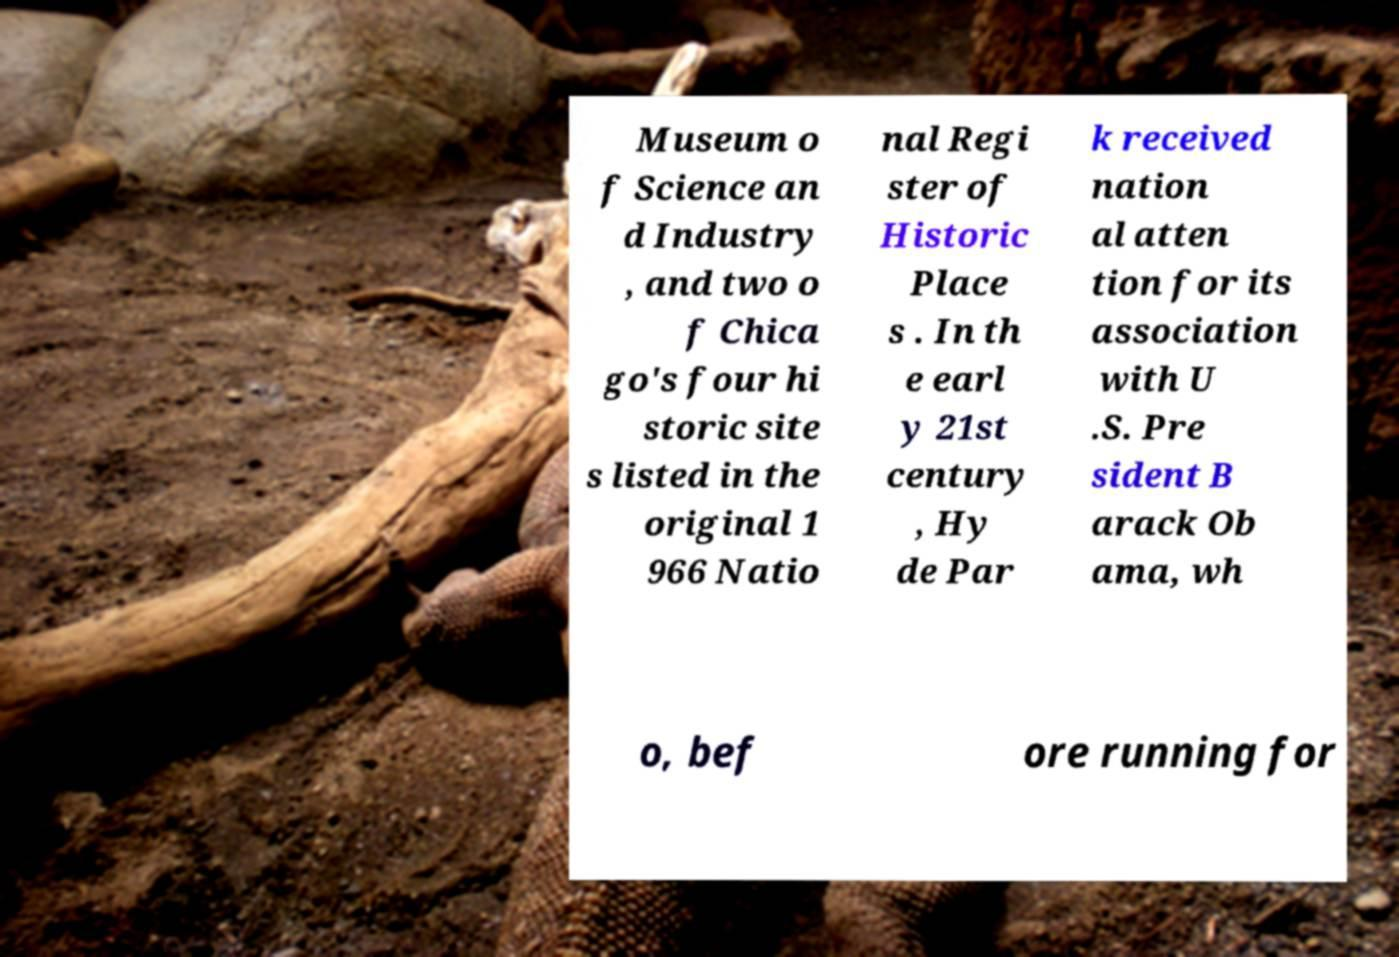Could you assist in decoding the text presented in this image and type it out clearly? Museum o f Science an d Industry , and two o f Chica go's four hi storic site s listed in the original 1 966 Natio nal Regi ster of Historic Place s . In th e earl y 21st century , Hy de Par k received nation al atten tion for its association with U .S. Pre sident B arack Ob ama, wh o, bef ore running for 